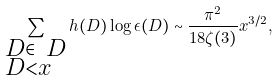<formula> <loc_0><loc_0><loc_500><loc_500>\sum _ { \begin{subarray} { c } D \in \ D \\ D < x \end{subarray} } h ( D ) \log { \epsilon ( D ) } \sim \frac { \pi ^ { 2 } } { 1 8 \zeta ( 3 ) } x ^ { 3 / 2 } ,</formula> 